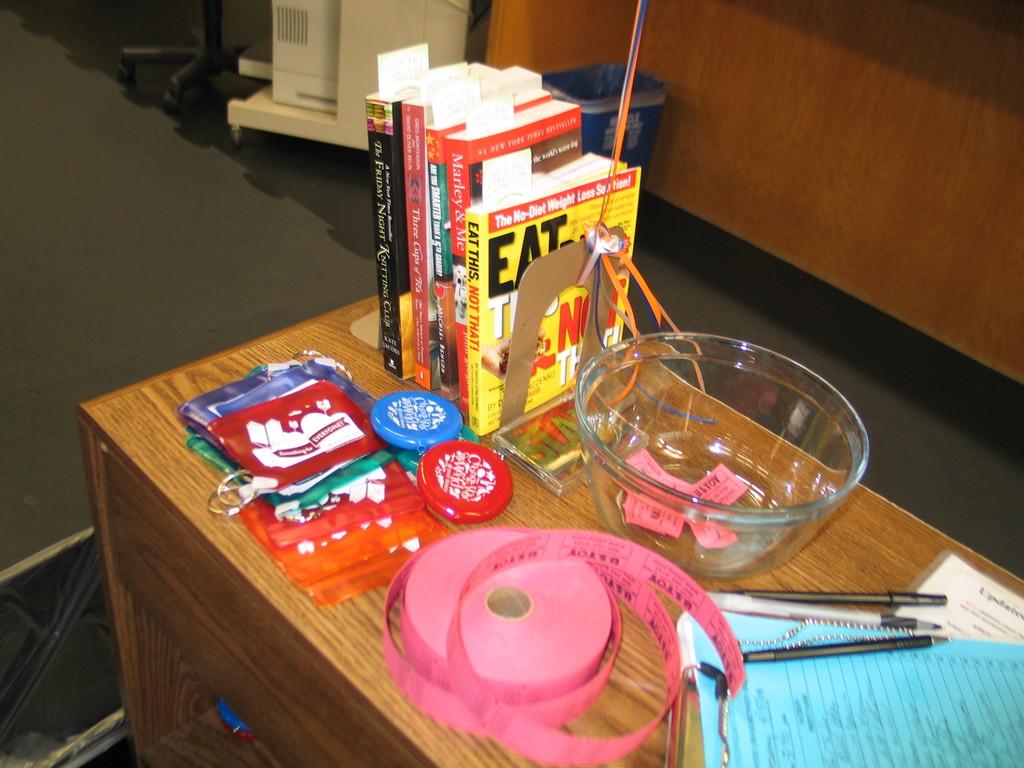What's the name of the book which contains the no-diet weight loss solution?
Provide a short and direct response. Eat this, not that!. There is a role of what on the table?
Offer a terse response. Answering does not require reading text in the image. 